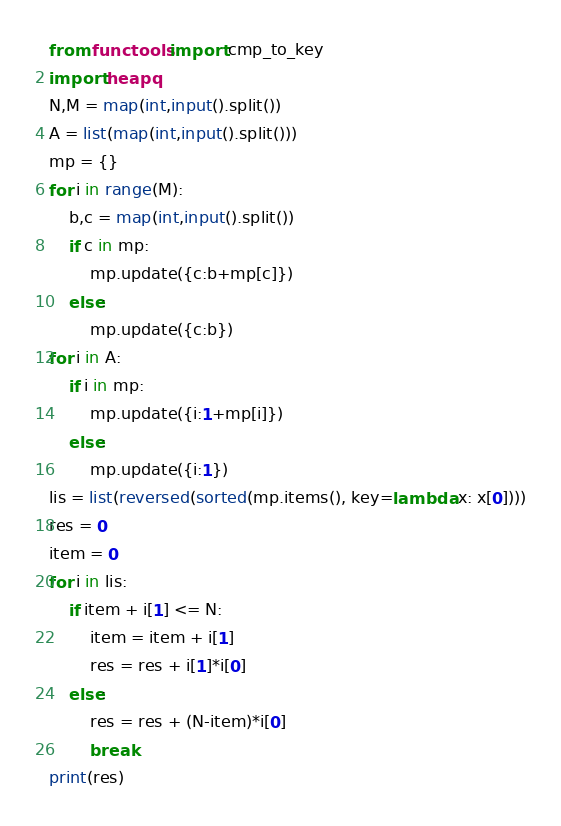Convert code to text. <code><loc_0><loc_0><loc_500><loc_500><_Python_>from functools import cmp_to_key
import heapq
N,M = map(int,input().split())
A = list(map(int,input().split()))
mp = {}
for i in range(M):
    b,c = map(int,input().split())
    if c in mp:
        mp.update({c:b+mp[c]})
    else:
        mp.update({c:b})
for i in A:
    if i in mp:
        mp.update({i:1+mp[i]})
    else:
        mp.update({i:1})
lis = list(reversed(sorted(mp.items(), key=lambda x: x[0])))
res = 0
item = 0
for i in lis:
    if item + i[1] <= N:
        item = item + i[1]
        res = res + i[1]*i[0]
    else:
        res = res + (N-item)*i[0]
        break
print(res)</code> 